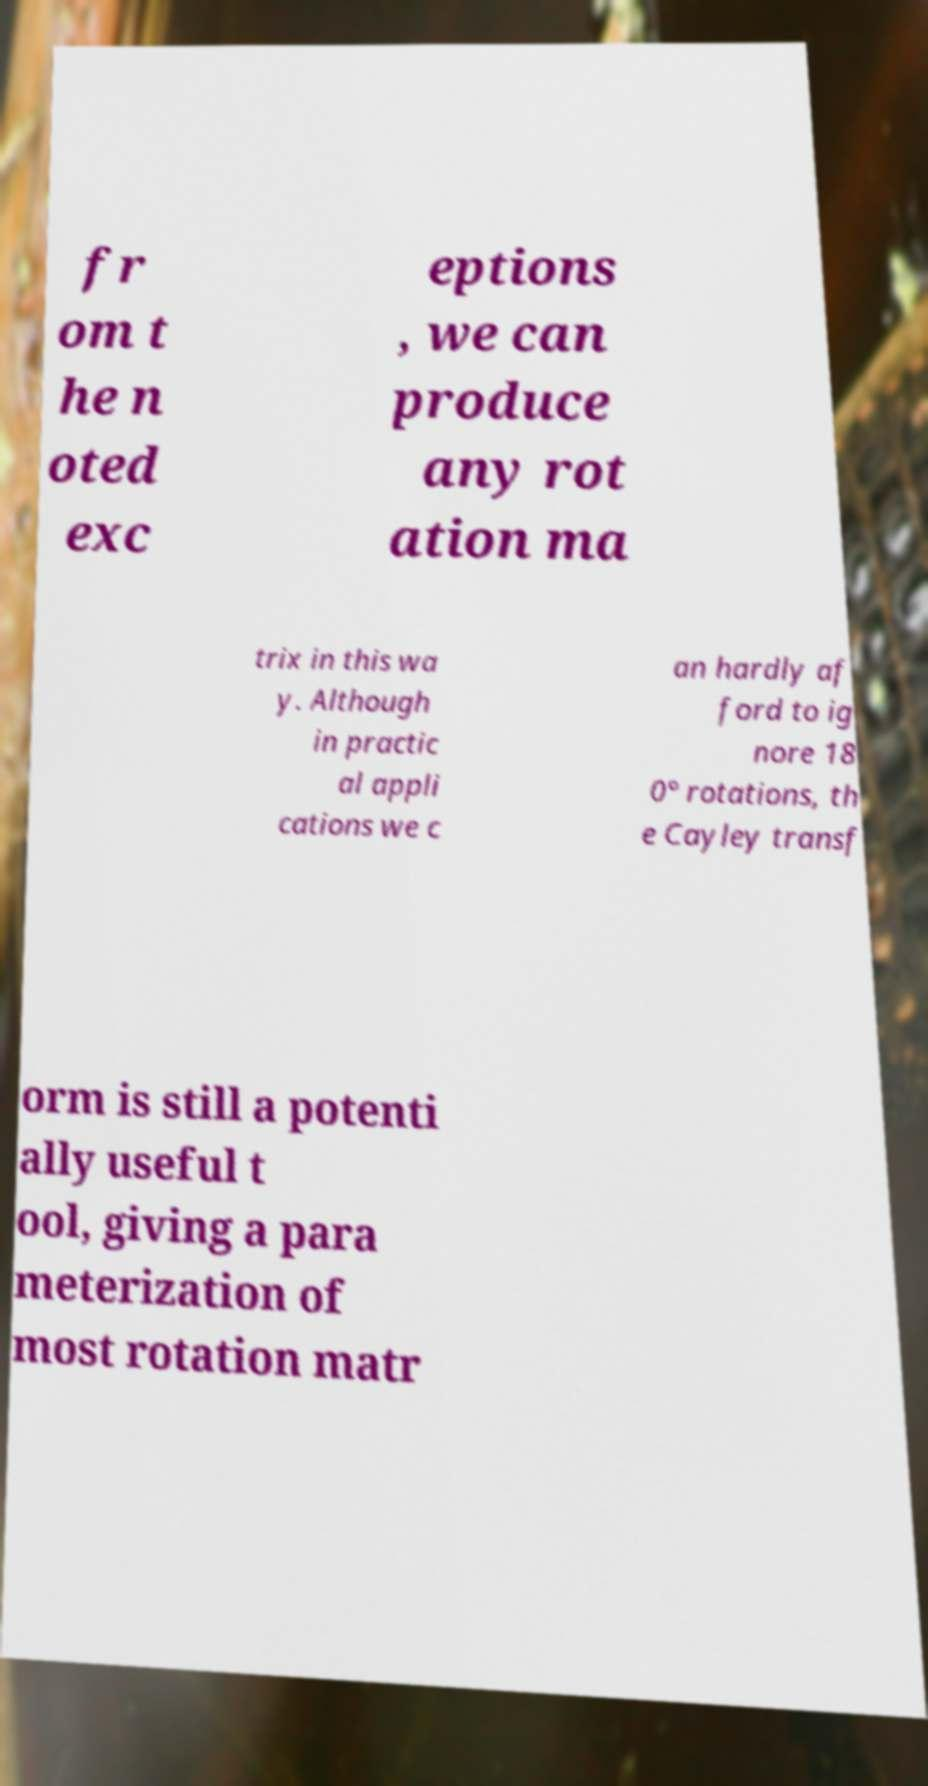There's text embedded in this image that I need extracted. Can you transcribe it verbatim? fr om t he n oted exc eptions , we can produce any rot ation ma trix in this wa y. Although in practic al appli cations we c an hardly af ford to ig nore 18 0° rotations, th e Cayley transf orm is still a potenti ally useful t ool, giving a para meterization of most rotation matr 